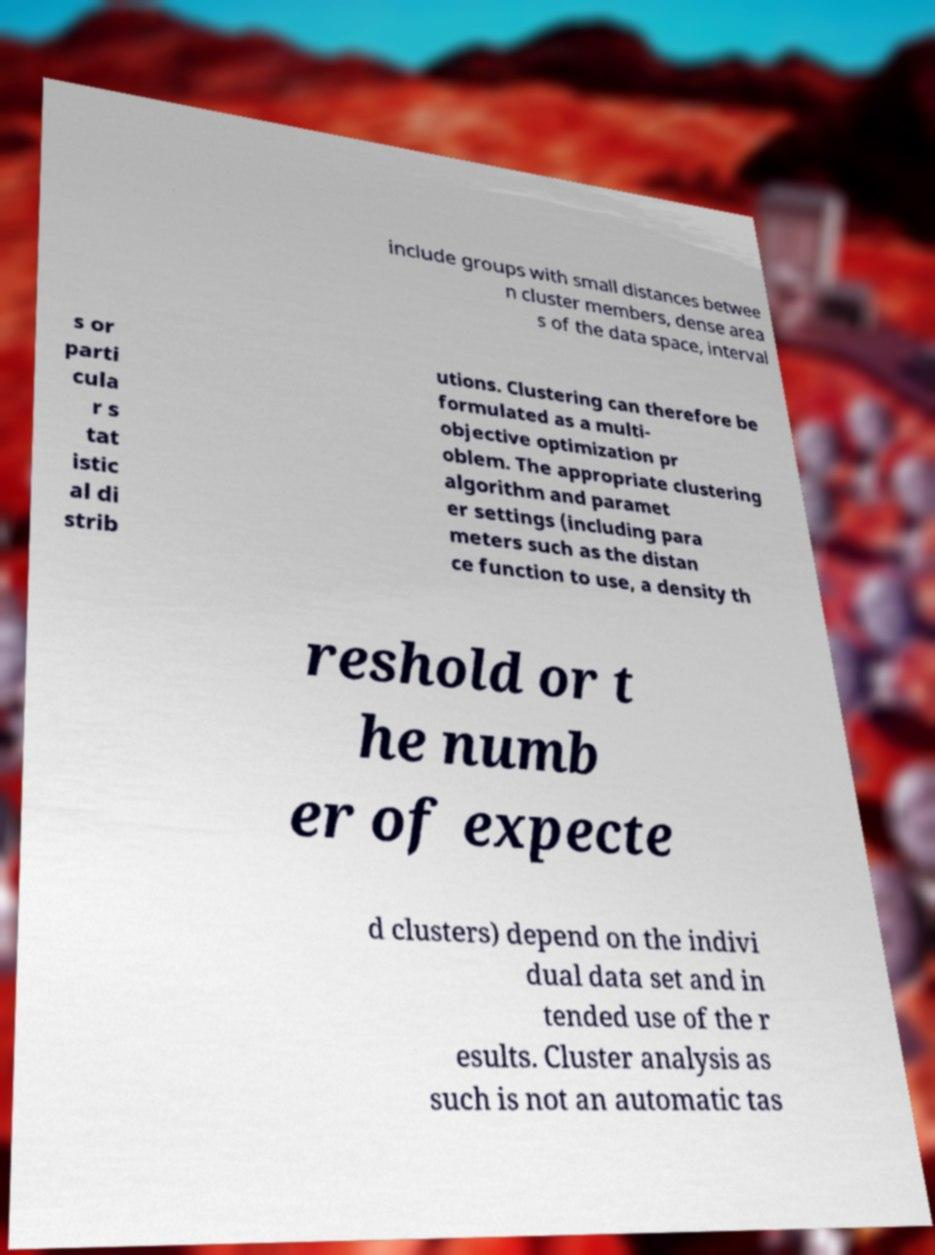Could you assist in decoding the text presented in this image and type it out clearly? include groups with small distances betwee n cluster members, dense area s of the data space, interval s or parti cula r s tat istic al di strib utions. Clustering can therefore be formulated as a multi- objective optimization pr oblem. The appropriate clustering algorithm and paramet er settings (including para meters such as the distan ce function to use, a density th reshold or t he numb er of expecte d clusters) depend on the indivi dual data set and in tended use of the r esults. Cluster analysis as such is not an automatic tas 